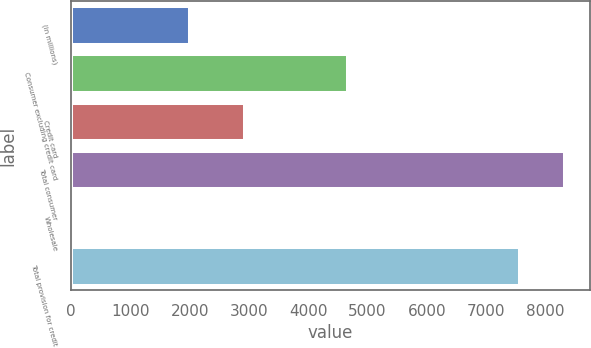Convert chart to OTSL. <chart><loc_0><loc_0><loc_500><loc_500><bar_chart><fcel>(in millions)<fcel>Consumer excluding credit card<fcel>Credit card<fcel>Total consumer<fcel>Wholesale<fcel>Total provision for credit<nl><fcel>2011<fcel>4672<fcel>2925<fcel>8331.4<fcel>23<fcel>7574<nl></chart> 